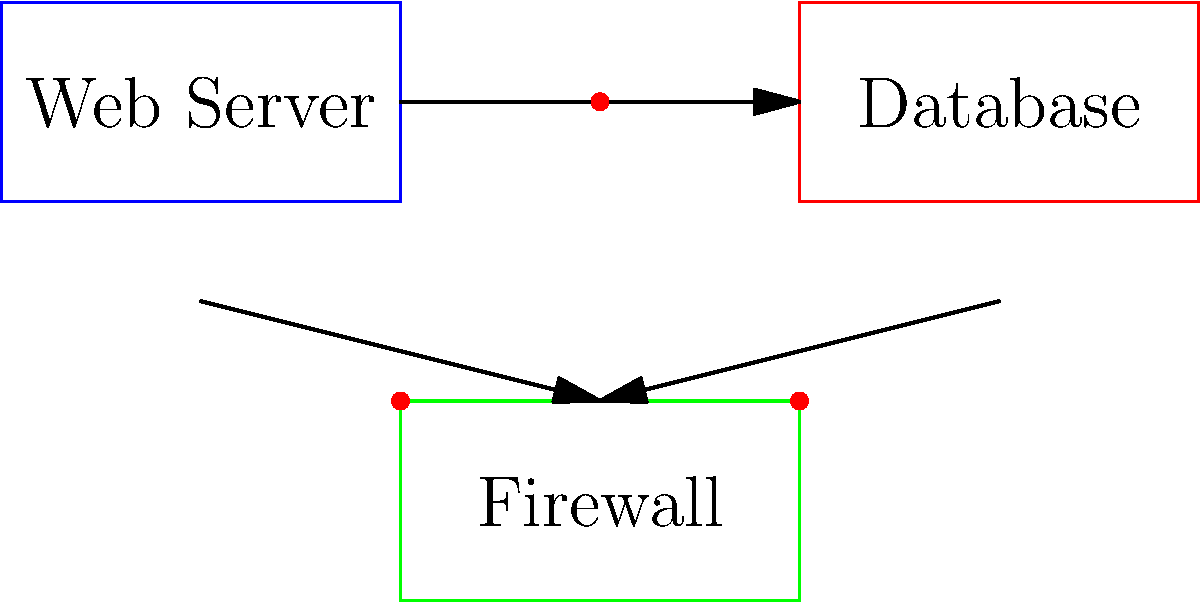Analyze the system architecture diagram above, which represents a basic web application setup. Identify and list the potential security vulnerabilities present in this configuration. Consider the components, their connections, and any missing security measures. To identify potential security vulnerabilities in the given system architecture, let's analyze each component and their interactions:

1. Web Server:
   - Directly exposed to the internet, making it a primary target for attacks.
   - Potential for unencrypted communication if HTTPS is not implemented.

2. Database:
   - Direct connection to the web server without an intermediate layer.
   - Possible unauthorized access if proper authentication is not in place.

3. Firewall:
   - Single firewall for both incoming and outgoing traffic.
   - Lack of segmentation between web and database tiers.

4. Missing Components:
   - No load balancer for distributing traffic and providing an additional layer of security.
   - Absence of a Web Application Firewall (WAF) to protect against application-layer attacks.
   - No Intrusion Detection/Prevention System (IDS/IPS) for monitoring and blocking malicious activities.

5. Network Configuration:
   - Direct communication between web server and database, bypassing the firewall.
   - Lack of network segmentation or DMZ (Demilitarized Zone) for the web server.

6. Authentication and Authorization:
   - No visible implementation of authentication mechanisms for database access.
   - Potential for unauthorized access between components.

7. Monitoring and Logging:
   - Absence of centralized logging or monitoring system for security events.

8. Data Protection:
   - No visible encryption for data in transit or at rest.

These vulnerabilities could lead to various security risks, including unauthorized access, data breaches, and potential for DDoS attacks.
Answer: 1. Exposed web server
2. Unsecured database connection
3. Single firewall
4. Lack of network segmentation
5. Missing WAF and IDS/IPS
6. Potential unencrypted communication
7. Absence of authentication mechanisms
8. Lack of monitoring and logging 